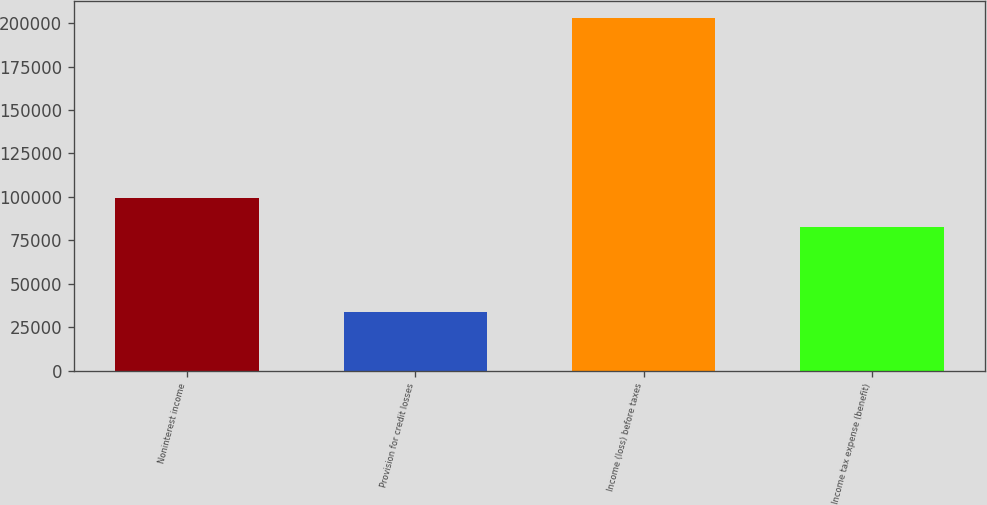Convert chart to OTSL. <chart><loc_0><loc_0><loc_500><loc_500><bar_chart><fcel>Noninterest income<fcel>Provision for credit losses<fcel>Income (loss) before taxes<fcel>Income tax expense (benefit)<nl><fcel>99607.7<fcel>33529<fcel>202746<fcel>82686<nl></chart> 